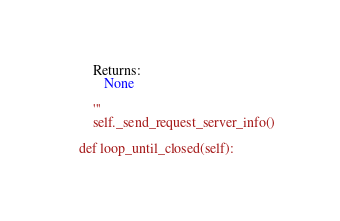<code> <loc_0><loc_0><loc_500><loc_500><_Python_>
        Returns:
           None

        '''
        self._send_request_server_info()

    def loop_until_closed(self):</code> 